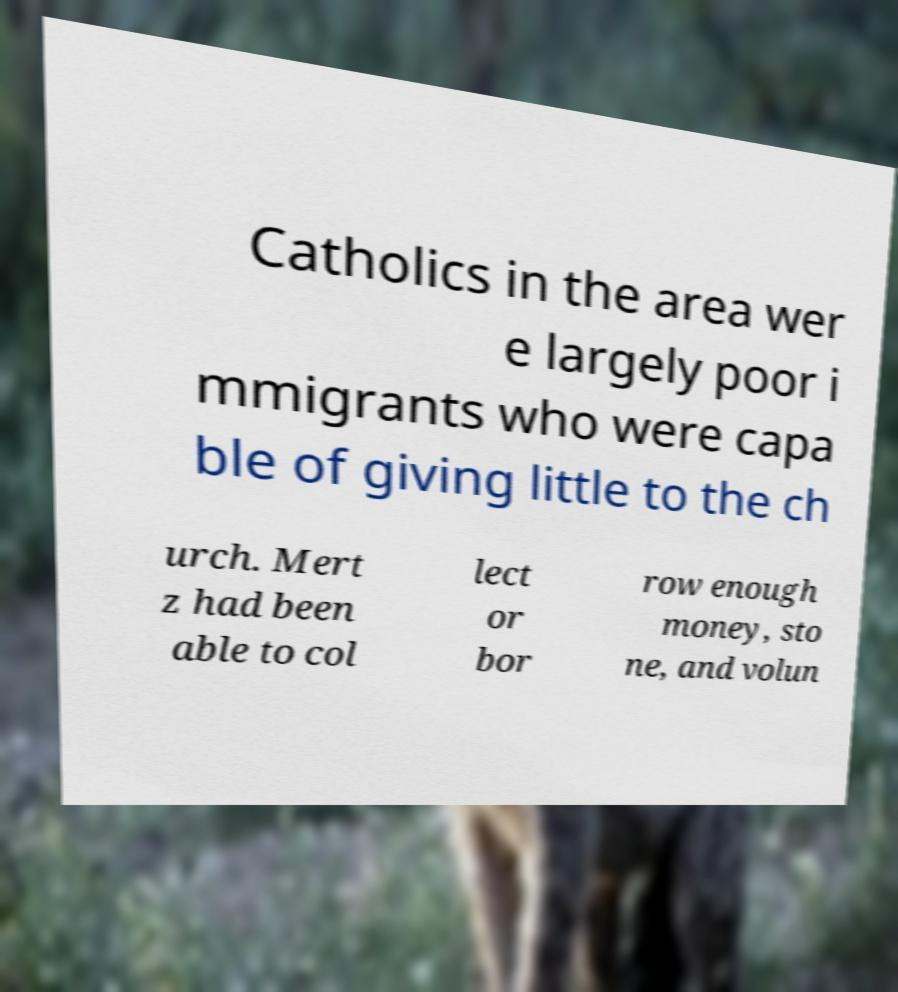Can you accurately transcribe the text from the provided image for me? Catholics in the area wer e largely poor i mmigrants who were capa ble of giving little to the ch urch. Mert z had been able to col lect or bor row enough money, sto ne, and volun 